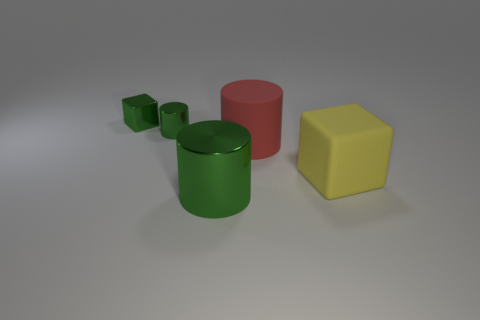Do the metal block and the large metallic cylinder have the same color?
Your answer should be compact. Yes. There is a big metallic cylinder in front of the big cylinder behind the green metallic object in front of the big red matte cylinder; what color is it?
Your answer should be compact. Green. Are there any other things of the same color as the metal cube?
Provide a succinct answer. Yes. What is the shape of the small shiny object that is the same color as the tiny block?
Make the answer very short. Cylinder. There is a green cylinder behind the yellow rubber block; how big is it?
Offer a very short reply. Small. There is a red object that is the same size as the yellow rubber thing; what shape is it?
Your answer should be very brief. Cylinder. Do the cylinder that is to the right of the large green metallic object and the block that is right of the small metallic cube have the same material?
Provide a short and direct response. Yes. The object to the right of the large cylinder behind the large metallic thing is made of what material?
Your answer should be very brief. Rubber. What is the size of the cube behind the small green metal thing that is in front of the cube behind the yellow rubber thing?
Offer a terse response. Small. Do the yellow thing and the green metal block have the same size?
Ensure brevity in your answer.  No. 